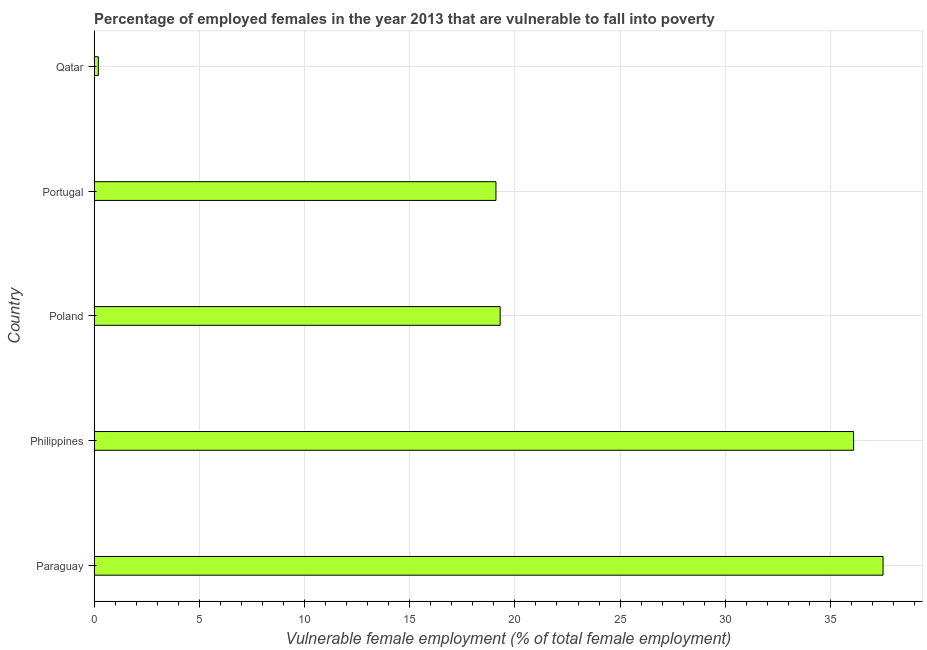Does the graph contain any zero values?
Your answer should be very brief. No. What is the title of the graph?
Offer a very short reply. Percentage of employed females in the year 2013 that are vulnerable to fall into poverty. What is the label or title of the X-axis?
Your response must be concise. Vulnerable female employment (% of total female employment). What is the percentage of employed females who are vulnerable to fall into poverty in Philippines?
Provide a short and direct response. 36.1. Across all countries, what is the maximum percentage of employed females who are vulnerable to fall into poverty?
Ensure brevity in your answer.  37.5. Across all countries, what is the minimum percentage of employed females who are vulnerable to fall into poverty?
Your response must be concise. 0.2. In which country was the percentage of employed females who are vulnerable to fall into poverty maximum?
Your response must be concise. Paraguay. In which country was the percentage of employed females who are vulnerable to fall into poverty minimum?
Your response must be concise. Qatar. What is the sum of the percentage of employed females who are vulnerable to fall into poverty?
Make the answer very short. 112.2. What is the difference between the percentage of employed females who are vulnerable to fall into poverty in Paraguay and Qatar?
Your answer should be compact. 37.3. What is the average percentage of employed females who are vulnerable to fall into poverty per country?
Offer a very short reply. 22.44. What is the median percentage of employed females who are vulnerable to fall into poverty?
Provide a short and direct response. 19.3. What is the ratio of the percentage of employed females who are vulnerable to fall into poverty in Philippines to that in Poland?
Provide a succinct answer. 1.87. Is the percentage of employed females who are vulnerable to fall into poverty in Paraguay less than that in Poland?
Your answer should be very brief. No. Is the difference between the percentage of employed females who are vulnerable to fall into poverty in Paraguay and Poland greater than the difference between any two countries?
Ensure brevity in your answer.  No. What is the difference between the highest and the lowest percentage of employed females who are vulnerable to fall into poverty?
Your answer should be compact. 37.3. How many bars are there?
Offer a terse response. 5. How many countries are there in the graph?
Your response must be concise. 5. What is the difference between two consecutive major ticks on the X-axis?
Make the answer very short. 5. What is the Vulnerable female employment (% of total female employment) of Paraguay?
Make the answer very short. 37.5. What is the Vulnerable female employment (% of total female employment) in Philippines?
Your answer should be compact. 36.1. What is the Vulnerable female employment (% of total female employment) of Poland?
Ensure brevity in your answer.  19.3. What is the Vulnerable female employment (% of total female employment) in Portugal?
Provide a succinct answer. 19.1. What is the Vulnerable female employment (% of total female employment) in Qatar?
Provide a succinct answer. 0.2. What is the difference between the Vulnerable female employment (% of total female employment) in Paraguay and Philippines?
Your answer should be compact. 1.4. What is the difference between the Vulnerable female employment (% of total female employment) in Paraguay and Poland?
Offer a terse response. 18.2. What is the difference between the Vulnerable female employment (% of total female employment) in Paraguay and Portugal?
Make the answer very short. 18.4. What is the difference between the Vulnerable female employment (% of total female employment) in Paraguay and Qatar?
Your response must be concise. 37.3. What is the difference between the Vulnerable female employment (% of total female employment) in Philippines and Poland?
Provide a succinct answer. 16.8. What is the difference between the Vulnerable female employment (% of total female employment) in Philippines and Qatar?
Give a very brief answer. 35.9. What is the difference between the Vulnerable female employment (% of total female employment) in Poland and Qatar?
Keep it short and to the point. 19.1. What is the ratio of the Vulnerable female employment (% of total female employment) in Paraguay to that in Philippines?
Keep it short and to the point. 1.04. What is the ratio of the Vulnerable female employment (% of total female employment) in Paraguay to that in Poland?
Your answer should be compact. 1.94. What is the ratio of the Vulnerable female employment (% of total female employment) in Paraguay to that in Portugal?
Your answer should be compact. 1.96. What is the ratio of the Vulnerable female employment (% of total female employment) in Paraguay to that in Qatar?
Your response must be concise. 187.5. What is the ratio of the Vulnerable female employment (% of total female employment) in Philippines to that in Poland?
Provide a short and direct response. 1.87. What is the ratio of the Vulnerable female employment (% of total female employment) in Philippines to that in Portugal?
Provide a short and direct response. 1.89. What is the ratio of the Vulnerable female employment (% of total female employment) in Philippines to that in Qatar?
Make the answer very short. 180.5. What is the ratio of the Vulnerable female employment (% of total female employment) in Poland to that in Qatar?
Your answer should be compact. 96.5. What is the ratio of the Vulnerable female employment (% of total female employment) in Portugal to that in Qatar?
Your answer should be very brief. 95.5. 